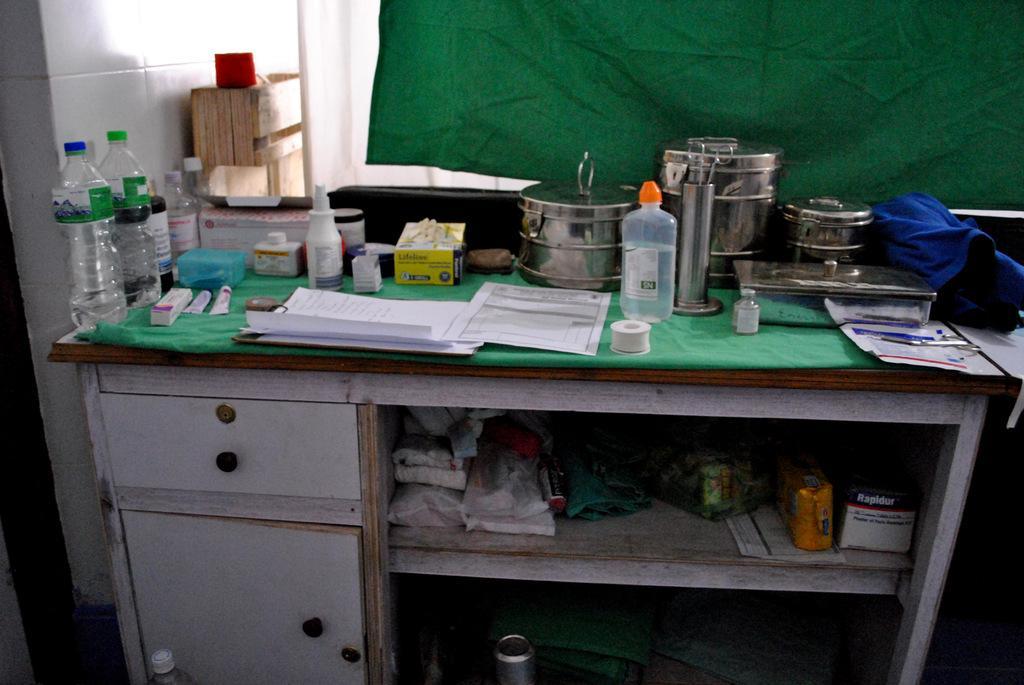How would you summarize this image in a sentence or two? In the foreground of this image, there is a table on which bottles, tubes, papers, boxes, tape, and scissors on the table. In the background, there is a green curtain and the wall. 